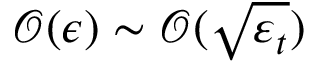Convert formula to latex. <formula><loc_0><loc_0><loc_500><loc_500>\mathcal { O } ( \epsilon ) \sim \mathcal { O } ( \sqrt { \varepsilon _ { t } } )</formula> 